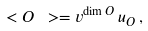Convert formula to latex. <formula><loc_0><loc_0><loc_500><loc_500>\ < O \ > = v ^ { \dim O } \, u _ { O } \, ,</formula> 